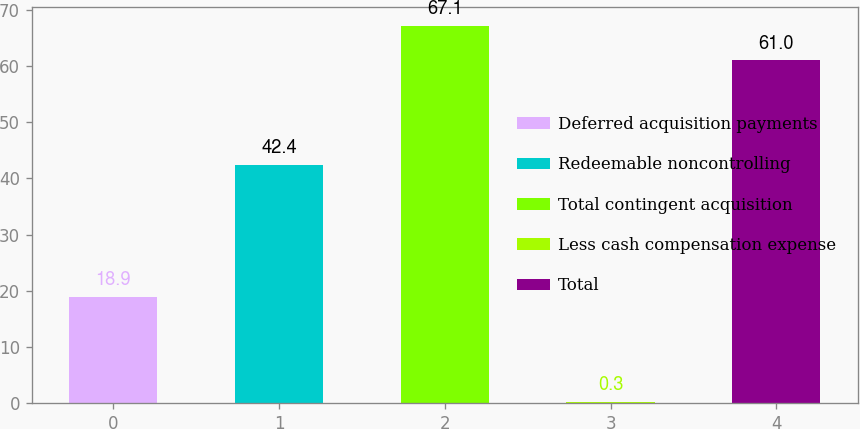<chart> <loc_0><loc_0><loc_500><loc_500><bar_chart><fcel>Deferred acquisition payments<fcel>Redeemable noncontrolling<fcel>Total contingent acquisition<fcel>Less cash compensation expense<fcel>Total<nl><fcel>18.9<fcel>42.4<fcel>67.1<fcel>0.3<fcel>61<nl></chart> 